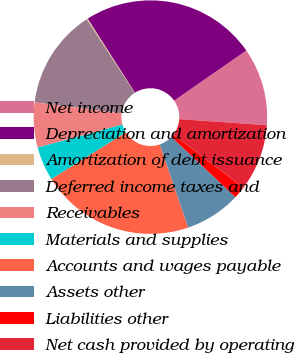Convert chart. <chart><loc_0><loc_0><loc_500><loc_500><pie_chart><fcel>Net income<fcel>Depreciation and amortization<fcel>Amortization of debt issuance<fcel>Deferred income taxes and<fcel>Receivables<fcel>Materials and supplies<fcel>Accounts and wages payable<fcel>Assets other<fcel>Liabilities other<fcel>Net cash provided by operating<nl><fcel>10.76%<fcel>24.37%<fcel>0.17%<fcel>13.78%<fcel>6.22%<fcel>4.71%<fcel>21.34%<fcel>7.73%<fcel>1.68%<fcel>9.24%<nl></chart> 